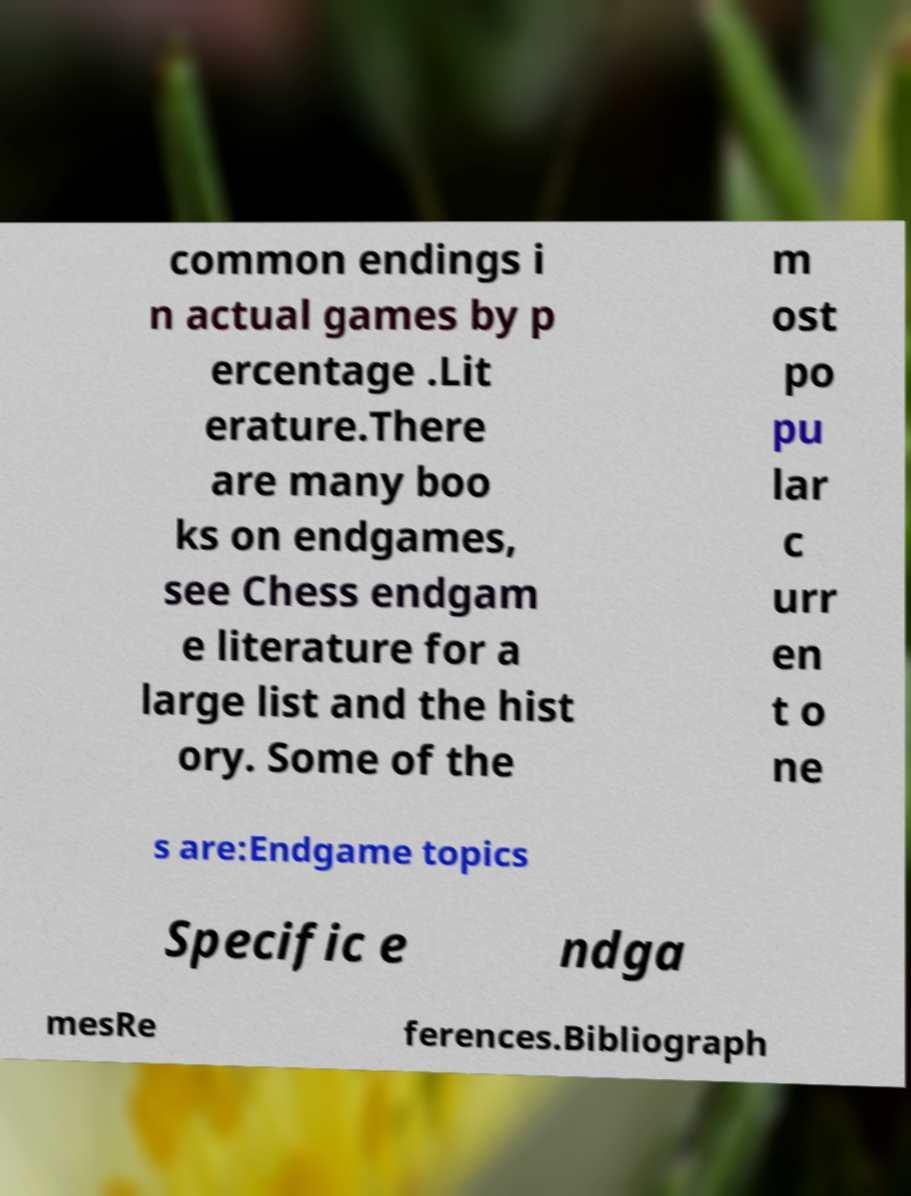What messages or text are displayed in this image? I need them in a readable, typed format. common endings i n actual games by p ercentage .Lit erature.There are many boo ks on endgames, see Chess endgam e literature for a large list and the hist ory. Some of the m ost po pu lar c urr en t o ne s are:Endgame topics Specific e ndga mesRe ferences.Bibliograph 